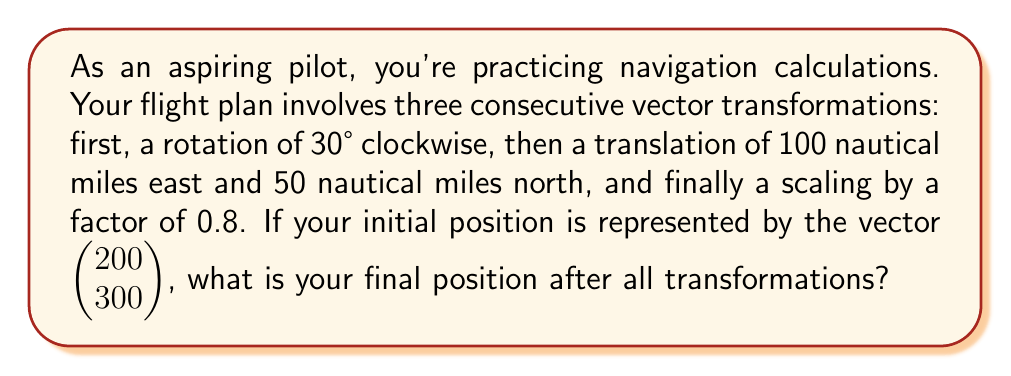Help me with this question. Let's break this down step-by-step:

1) First, we need to create the transformation matrices:

   Rotation matrix (30° clockwise): 
   $$R = \begin{pmatrix} \cos 30° & \sin 30° \\ -\sin 30° & \cos 30° \end{pmatrix} = \begin{pmatrix} \frac{\sqrt{3}}{2} & \frac{1}{2} \\ -\frac{1}{2} & \frac{\sqrt{3}}{2} \end{pmatrix}$$

   Translation matrix:
   $$T = \begin{pmatrix} 100 \\ 50 \end{pmatrix}$$

   Scaling matrix:
   $$S = \begin{pmatrix} 0.8 & 0 \\ 0 & 0.8 \end{pmatrix}$$

2) Now, let's apply these transformations in order:

   a) Rotation:
      $$\begin{pmatrix} \frac{\sqrt{3}}{2} & \frac{1}{2} \\ -\frac{1}{2} & \frac{\sqrt{3}}{2} \end{pmatrix} \begin{pmatrix} 200 \\ 300 \end{pmatrix} = \begin{pmatrix} \frac{\sqrt{3}}{2}(200) + \frac{1}{2}(300) \\ -\frac{1}{2}(200) + \frac{\sqrt{3}}{2}(300) \end{pmatrix} = \begin{pmatrix} 173.21 + 150 \\ -100 + 259.81 \end{pmatrix} = \begin{pmatrix} 323.21 \\ 159.81 \end{pmatrix}$$

   b) Translation:
      $$\begin{pmatrix} 323.21 \\ 159.81 \end{pmatrix} + \begin{pmatrix} 100 \\ 50 \end{pmatrix} = \begin{pmatrix} 423.21 \\ 209.81 \end{pmatrix}$$

   c) Scaling:
      $$\begin{pmatrix} 0.8 & 0 \\ 0 & 0.8 \end{pmatrix} \begin{pmatrix} 423.21 \\ 209.81 \end{pmatrix} = \begin{pmatrix} 0.8(423.21) \\ 0.8(209.81) \end{pmatrix} = \begin{pmatrix} 338.57 \\ 167.85 \end{pmatrix}$$

3) Therefore, the final position after all transformations is approximately $\begin{pmatrix} 338.57 \\ 167.85 \end{pmatrix}$.
Answer: $\begin{pmatrix} 338.57 \\ 167.85 \end{pmatrix}$ 